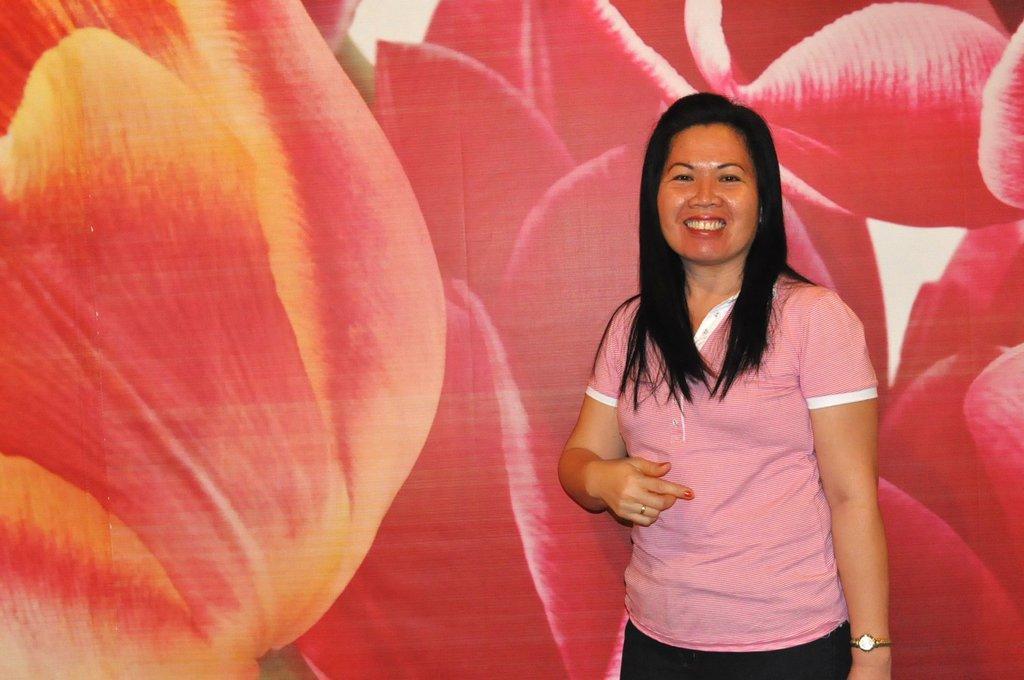Can you describe this image briefly? In this image we can see a person. Behind the person we can see the picture of the flowers. 